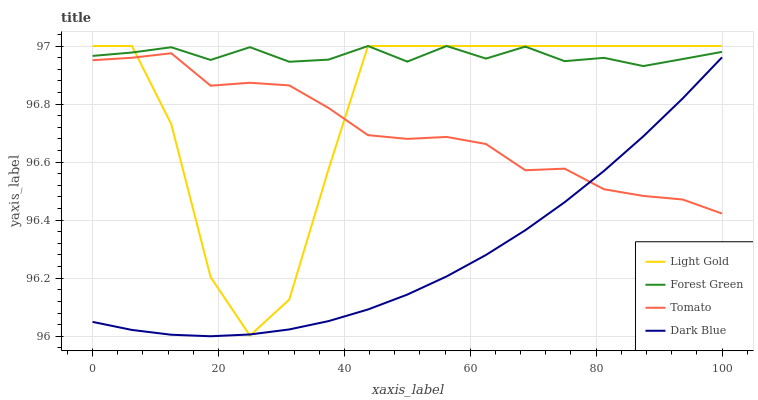Does Forest Green have the minimum area under the curve?
Answer yes or no. No. Does Dark Blue have the maximum area under the curve?
Answer yes or no. No. Is Forest Green the smoothest?
Answer yes or no. No. Is Forest Green the roughest?
Answer yes or no. No. Does Forest Green have the lowest value?
Answer yes or no. No. Does Dark Blue have the highest value?
Answer yes or no. No. Is Dark Blue less than Forest Green?
Answer yes or no. Yes. Is Forest Green greater than Dark Blue?
Answer yes or no. Yes. Does Dark Blue intersect Forest Green?
Answer yes or no. No. 